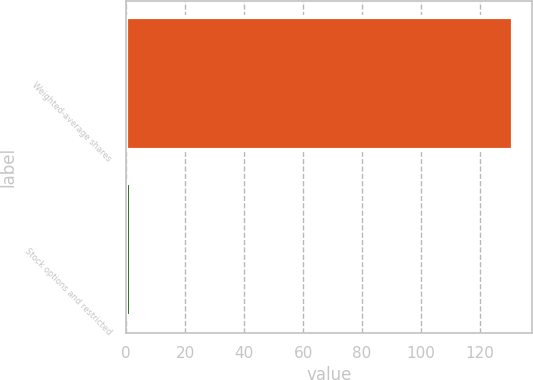Convert chart. <chart><loc_0><loc_0><loc_500><loc_500><bar_chart><fcel>Weighted-average shares<fcel>Stock options and restricted<nl><fcel>131.23<fcel>1.8<nl></chart> 